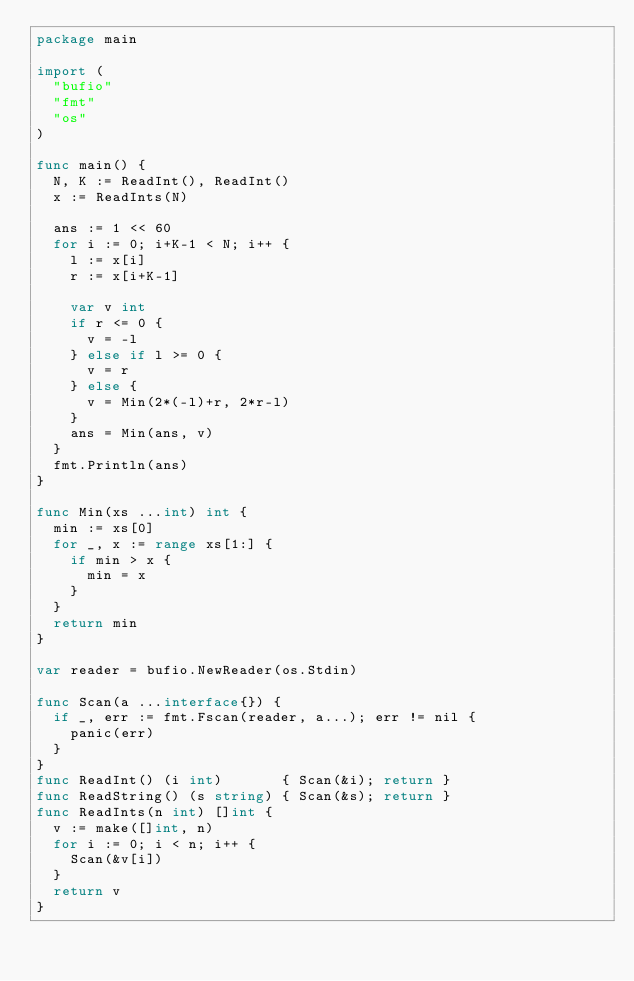Convert code to text. <code><loc_0><loc_0><loc_500><loc_500><_Go_>package main

import (
	"bufio"
	"fmt"
	"os"
)

func main() {
	N, K := ReadInt(), ReadInt()
	x := ReadInts(N)

	ans := 1 << 60
	for i := 0; i+K-1 < N; i++ {
		l := x[i]
		r := x[i+K-1]

		var v int
		if r <= 0 {
			v = -l
		} else if l >= 0 {
			v = r
		} else {
			v = Min(2*(-l)+r, 2*r-l)
		}
		ans = Min(ans, v)
	}
	fmt.Println(ans)
}

func Min(xs ...int) int {
	min := xs[0]
	for _, x := range xs[1:] {
		if min > x {
			min = x
		}
	}
	return min
}

var reader = bufio.NewReader(os.Stdin)

func Scan(a ...interface{}) {
	if _, err := fmt.Fscan(reader, a...); err != nil {
		panic(err)
	}
}
func ReadInt() (i int)       { Scan(&i); return }
func ReadString() (s string) { Scan(&s); return }
func ReadInts(n int) []int {
	v := make([]int, n)
	for i := 0; i < n; i++ {
		Scan(&v[i])
	}
	return v
}
</code> 